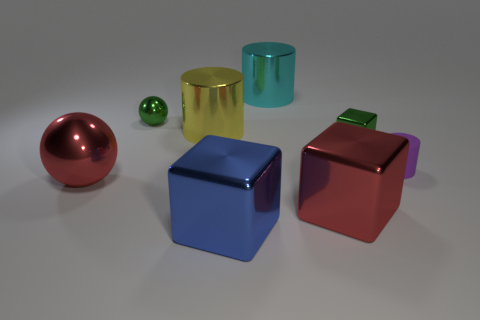Add 1 large cylinders. How many objects exist? 9 Subtract all cylinders. How many objects are left? 5 Subtract 0 brown cubes. How many objects are left? 8 Subtract all tiny cubes. Subtract all rubber things. How many objects are left? 6 Add 5 blue cubes. How many blue cubes are left? 6 Add 4 tiny blue matte cylinders. How many tiny blue matte cylinders exist? 4 